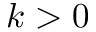Convert formula to latex. <formula><loc_0><loc_0><loc_500><loc_500>k > 0</formula> 